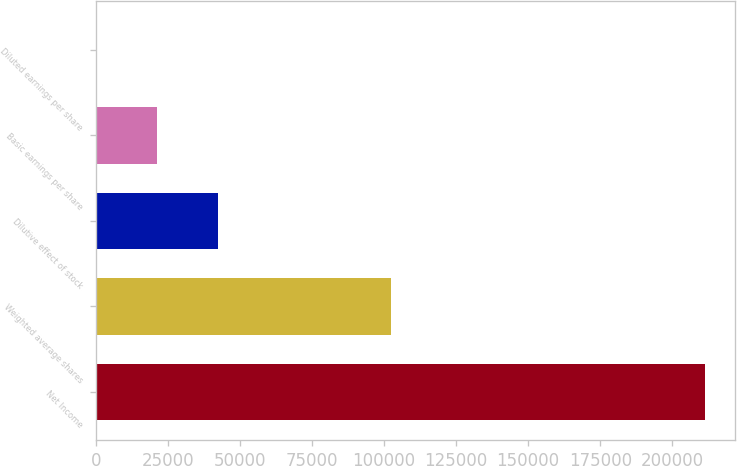<chart> <loc_0><loc_0><loc_500><loc_500><bar_chart><fcel>Net Income<fcel>Weighted average shares<fcel>Dilutive effect of stock<fcel>Basic earnings per share<fcel>Diluted earnings per share<nl><fcel>211221<fcel>102475<fcel>42246.3<fcel>21124.4<fcel>2.59<nl></chart> 